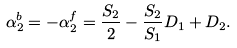<formula> <loc_0><loc_0><loc_500><loc_500>\alpha _ { 2 } ^ { b } = - \alpha _ { 2 } ^ { f } = \frac { S _ { 2 } } { 2 } - \frac { S _ { 2 } } { S _ { 1 } } D _ { 1 } + D _ { 2 } .</formula> 